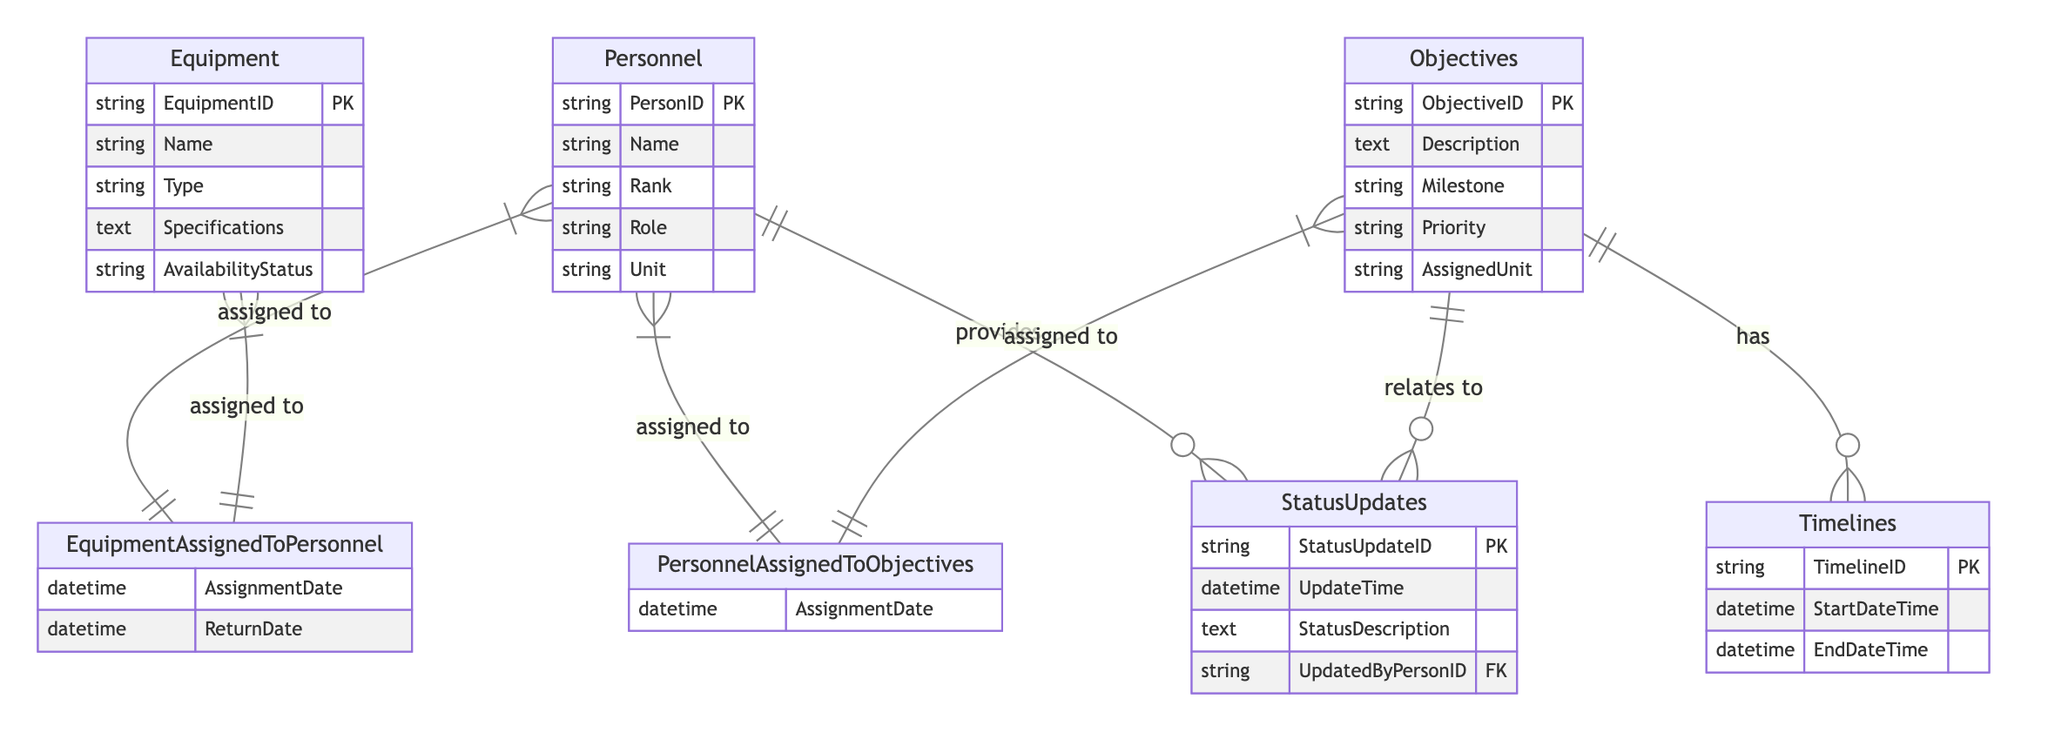What is the primary key for the Personnel entity? The primary key for the Personnel entity is the "PersonID". This is indicated directly in the diagram where the key attributes are listed under personnel.
Answer: PersonID How many attributes are there in the Equipment entity? The Equipment entity has five attributes listed: EquipmentID, Name, Type, Specifications, and AvailabilityStatus. Counting these gives a total of five.
Answer: 5 What type of relationship exists between Objectives and Timelines? The relationship between Objectives and Timelines is defined as "One-to-Many", which means one objective can have many associated timelines. This is indicated in the diagram.
Answer: One-to-Many Which entity provides status updates? The Personnel entity is the one that provides status updates, as shown by the "provides" relationship connecting Personnel to StatusUpdates.
Answer: Personnel How many relationships involve the Personnel entity? The Personnel entity is involved in four relationships: "provides" with StatusUpdates, "assigned to" with EquipmentAssignedToPersonnel, "assigned to" with PersonnelAssignedToObjectives, and "assigned to" with Equipment. Counting these, there are four distinct relationships.
Answer: 4 What attribute describes the availability of equipment? The availability of equipment is described by the attribute "AvailabilityStatus". This attribute is specifically listed in the Equipment entity's attributes.
Answer: AvailabilityStatus Which entity has a primary key of ObjectiveID? The Objectives entity has a primary key of "ObjectiveID". This is clearly indicated in the list of attributes for Objectives in the diagram.
Answer: Objectives How does the StatusUpdates relate to the Objectives? StatusUpdates relate to Objectives through a "One-to-Many" relationship; this implies that a single objective can have multiple status updates associated with it. This is shown by the connecting line with the "relates to" label.
Answer: One-to-Many What is the foreign key in the StatusUpdates entity? The foreign key in the StatusUpdates entity is "UpdatedByPersonID". This is indicated in the attributes of the StatusUpdates entity.
Answer: UpdatedByPersonID 